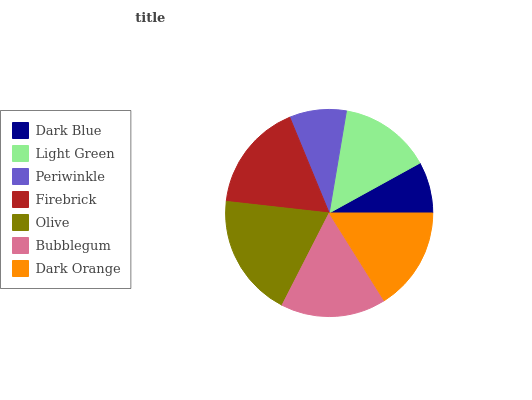Is Dark Blue the minimum?
Answer yes or no. Yes. Is Olive the maximum?
Answer yes or no. Yes. Is Light Green the minimum?
Answer yes or no. No. Is Light Green the maximum?
Answer yes or no. No. Is Light Green greater than Dark Blue?
Answer yes or no. Yes. Is Dark Blue less than Light Green?
Answer yes or no. Yes. Is Dark Blue greater than Light Green?
Answer yes or no. No. Is Light Green less than Dark Blue?
Answer yes or no. No. Is Dark Orange the high median?
Answer yes or no. Yes. Is Dark Orange the low median?
Answer yes or no. Yes. Is Olive the high median?
Answer yes or no. No. Is Dark Blue the low median?
Answer yes or no. No. 